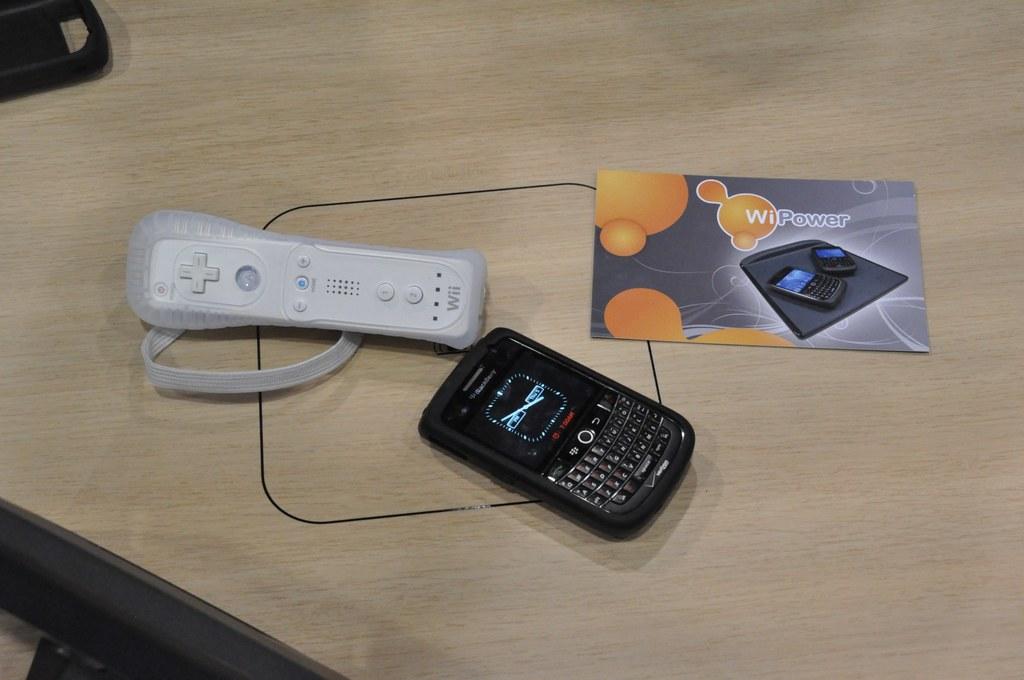What brand of phone is that?
Make the answer very short. Blackberry. What is the title of the phamplet?
Give a very brief answer. Wipower. 